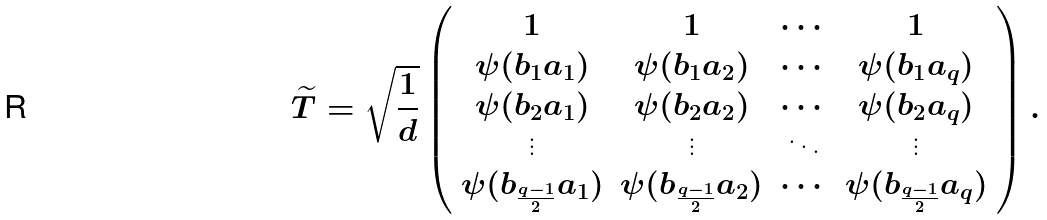Convert formula to latex. <formula><loc_0><loc_0><loc_500><loc_500>\widetilde { T } = \sqrt { \frac { 1 } { d } } \left ( \begin{array} { c c c c } 1 & 1 & \cdots & 1 \\ \psi ( b _ { 1 } a _ { 1 } ) & \psi ( b _ { 1 } a _ { 2 } ) & \cdots & \psi ( b _ { 1 } a _ { q } ) \\ \psi ( b _ { 2 } a _ { 1 } ) & \psi ( b _ { 2 } a _ { 2 } ) & \cdots & \psi ( b _ { 2 } a _ { q } ) \\ \vdots & \vdots & \ddots & \vdots \\ \psi ( b _ { \frac { q - 1 } { 2 } } a _ { 1 } ) & \psi ( b _ { \frac { q - 1 } { 2 } } a _ { 2 } ) & \cdots & \psi ( b _ { \frac { q - 1 } { 2 } } a _ { q } ) \end{array} \right ) .</formula> 